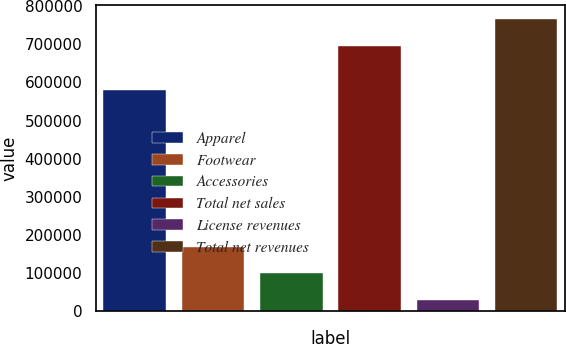Convert chart to OTSL. <chart><loc_0><loc_0><loc_500><loc_500><bar_chart><fcel>Apparel<fcel>Footwear<fcel>Accessories<fcel>Total net sales<fcel>License revenues<fcel>Total net revenues<nl><fcel>578887<fcel>169018<fcel>99490.2<fcel>695282<fcel>29962<fcel>764810<nl></chart> 